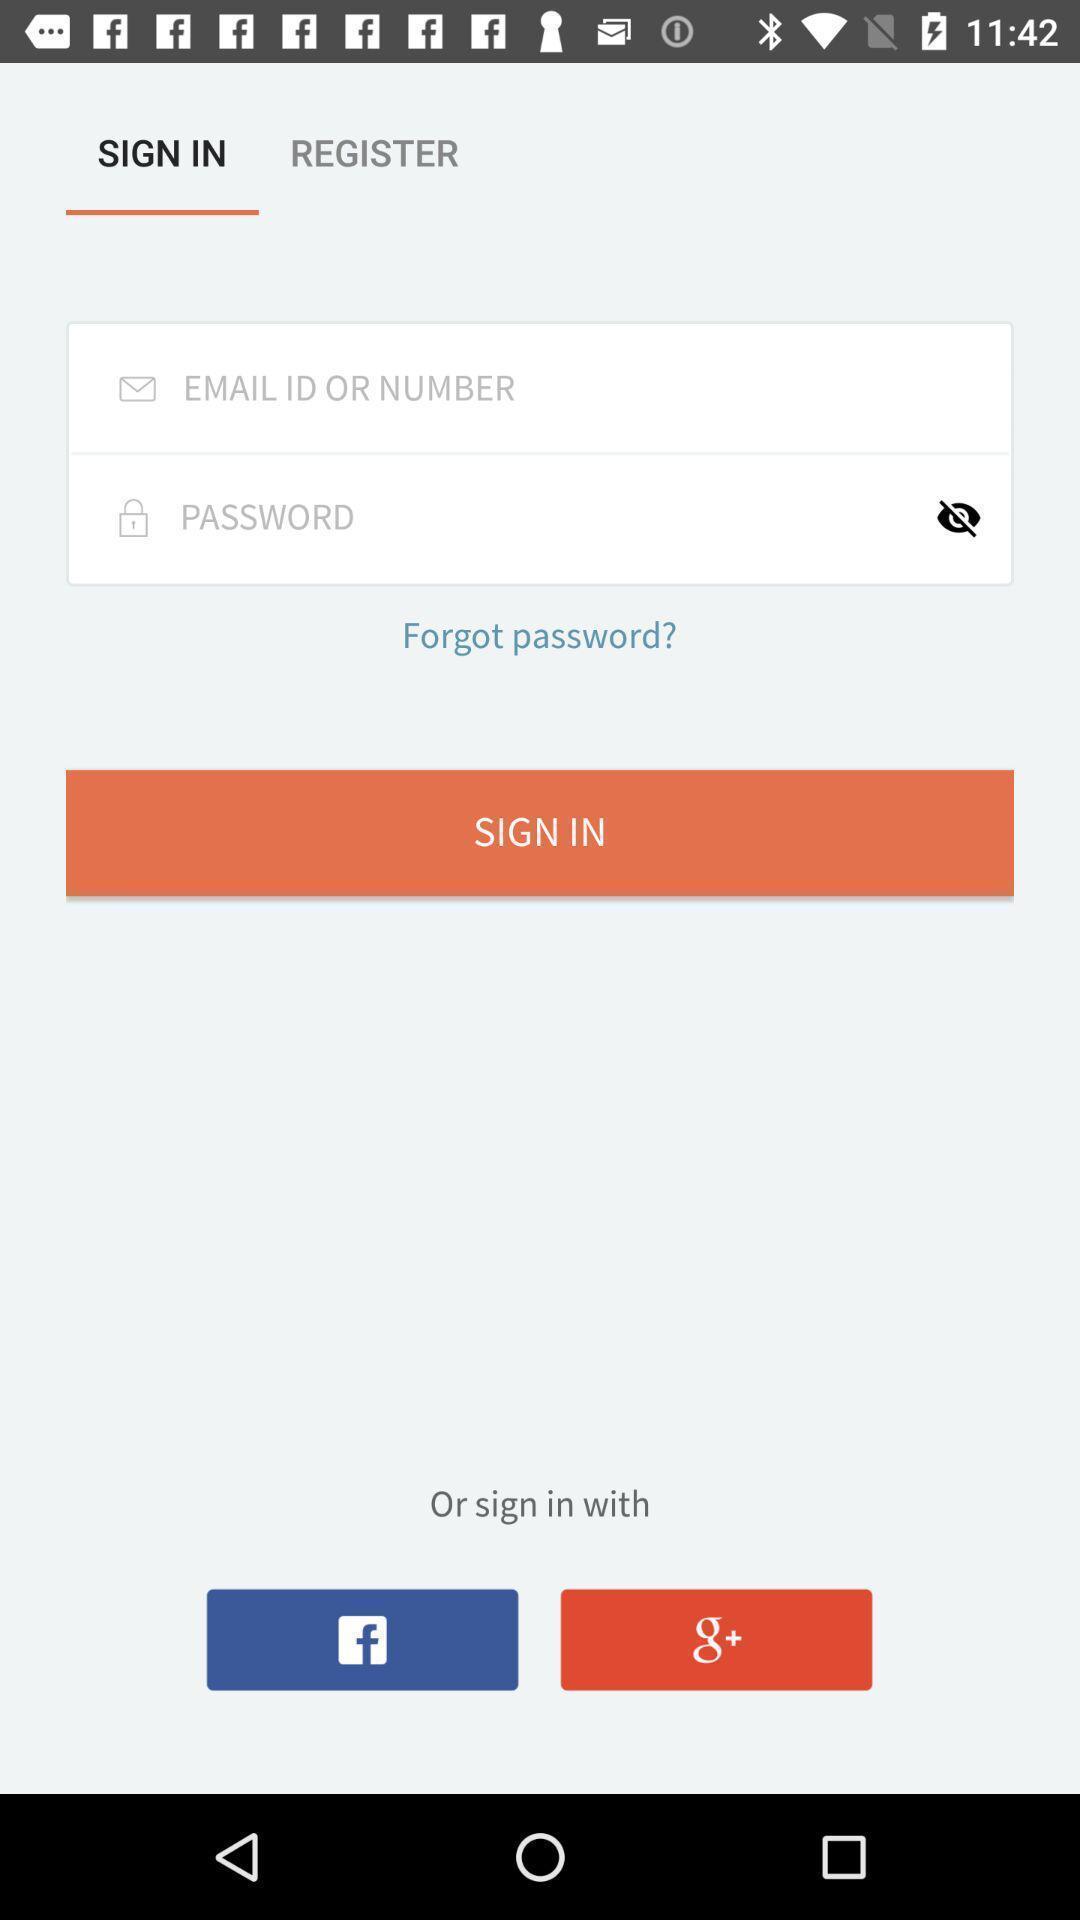Summarize the information in this screenshot. Welcome page displaying login details. 